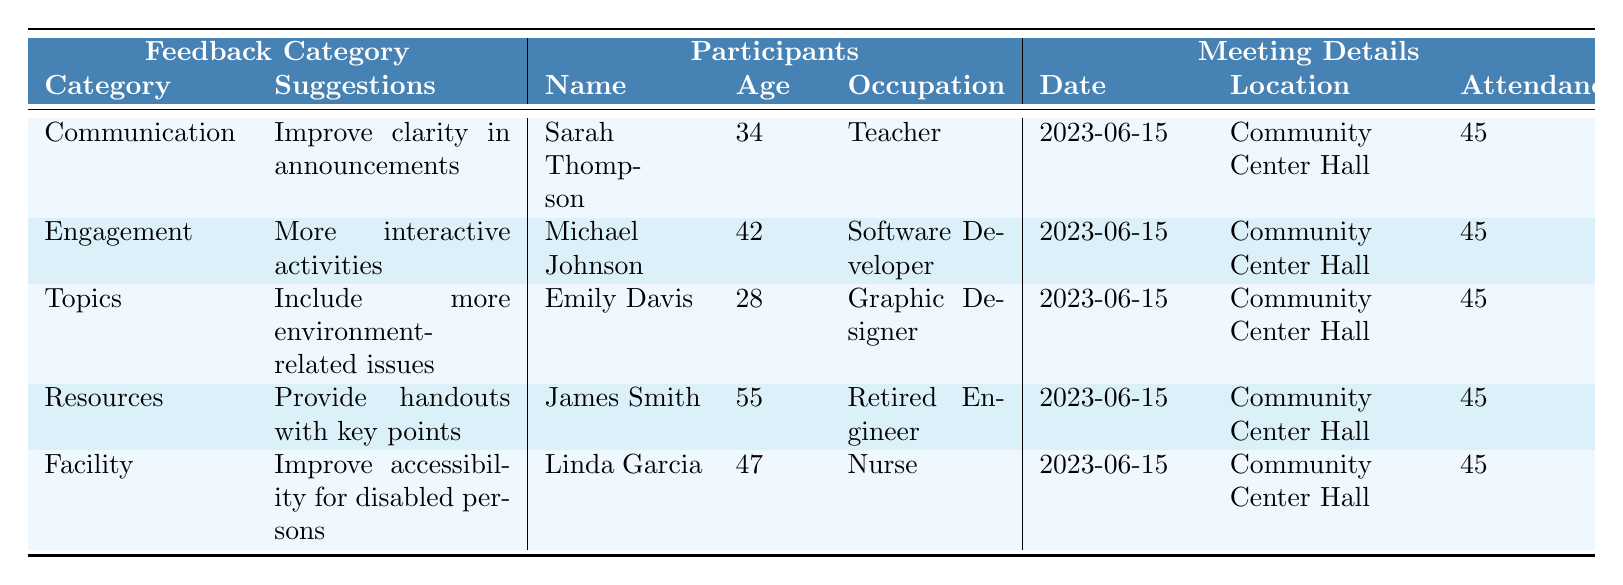What is the age of Sarah Thompson? Sarah Thompson is listed in the table under the Participants section, and her age is provided as 34.
Answer: 34 How many participants are there in total? The table lists 5 participants, each with their details.
Answer: 5 Which feedback category had the suggestion to improve clarity in announcements? The feedback category of Communication contains the suggestion to improve clarity in announcements, as stated in the table.
Answer: Communication Did any participants suggest including more environment-related issues? Yes, Emily Davis suggested including more environment-related issues, as indicated under the Topics category in the feedback.
Answer: Yes What is the average age of the participants? To find the average age, sum the ages (34 + 42 + 28 + 55 + 47 = 206) and divide by the number of participants (5). The average age is 206/5 = 41.2.
Answer: 41.2 How many participants were in attendance at the town hall meeting? The Attendance column shows that there were 45 participants in attendance at the town hall meeting.
Answer: 45 Was the meeting location the Community Center Hall? Yes, all entries in the Location column indicate the meeting took place at the Community Center Hall.
Answer: Yes What is the feedback category with the highest age of participants? Analyzing the ages, James Smith (55) from the Resources category is the oldest. No other category has an older participant than him.
Answer: Resources Which suggestion relates to improving accessibility? The suggestion to improve accessibility for disabled persons is found under the Facility category.
Answer: Facility Are most suggestions related to engagement or communication? Both categories have one suggestion each, but "Engagement" relates to interaction, while "Communication" focuses on clarity, making them equally counted.
Answer: They are equal 